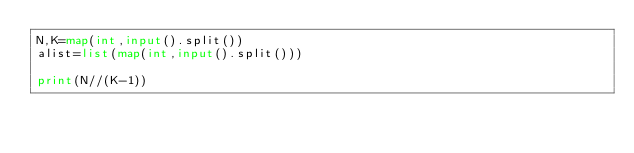<code> <loc_0><loc_0><loc_500><loc_500><_Python_>N,K=map(int,input().split())
alist=list(map(int,input().split()))

print(N//(K-1))</code> 